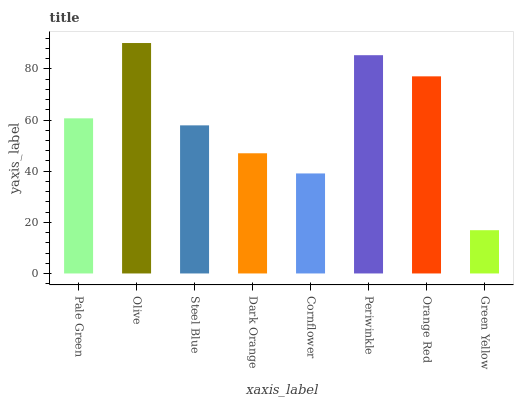Is Green Yellow the minimum?
Answer yes or no. Yes. Is Olive the maximum?
Answer yes or no. Yes. Is Steel Blue the minimum?
Answer yes or no. No. Is Steel Blue the maximum?
Answer yes or no. No. Is Olive greater than Steel Blue?
Answer yes or no. Yes. Is Steel Blue less than Olive?
Answer yes or no. Yes. Is Steel Blue greater than Olive?
Answer yes or no. No. Is Olive less than Steel Blue?
Answer yes or no. No. Is Pale Green the high median?
Answer yes or no. Yes. Is Steel Blue the low median?
Answer yes or no. Yes. Is Steel Blue the high median?
Answer yes or no. No. Is Orange Red the low median?
Answer yes or no. No. 